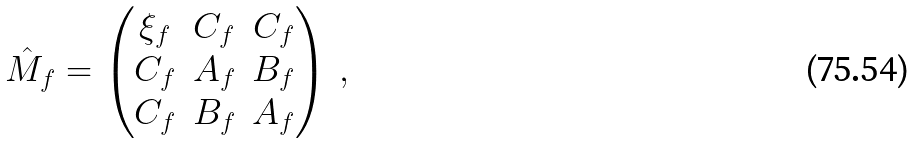Convert formula to latex. <formula><loc_0><loc_0><loc_500><loc_500>\hat { M } _ { f } = \begin{pmatrix} \xi _ { f } & C _ { f } & C _ { f } \\ C _ { f } & A _ { f } & B _ { f } \\ C _ { f } & B _ { f } & A _ { f } \end{pmatrix} \, ,</formula> 